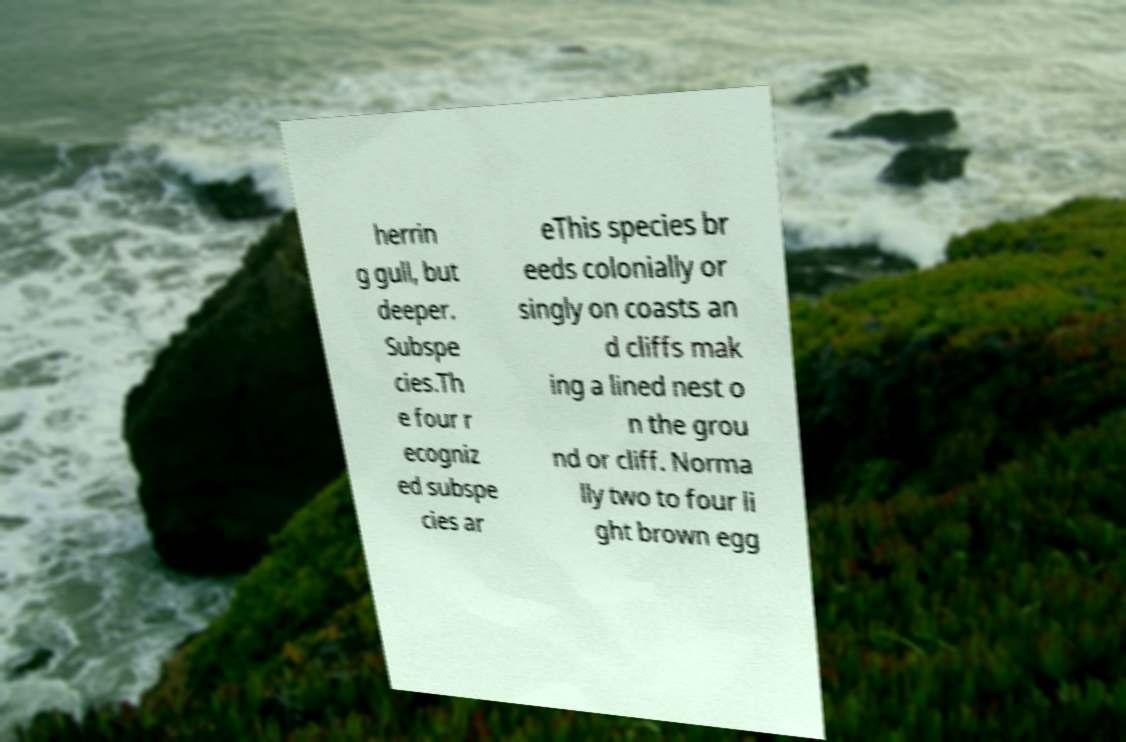Could you extract and type out the text from this image? herrin g gull, but deeper. Subspe cies.Th e four r ecogniz ed subspe cies ar eThis species br eeds colonially or singly on coasts an d cliffs mak ing a lined nest o n the grou nd or cliff. Norma lly two to four li ght brown egg 